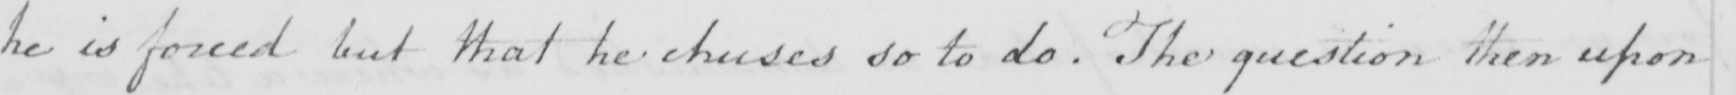What does this handwritten line say? he is forced but that he chuses so to do . The question then upon 